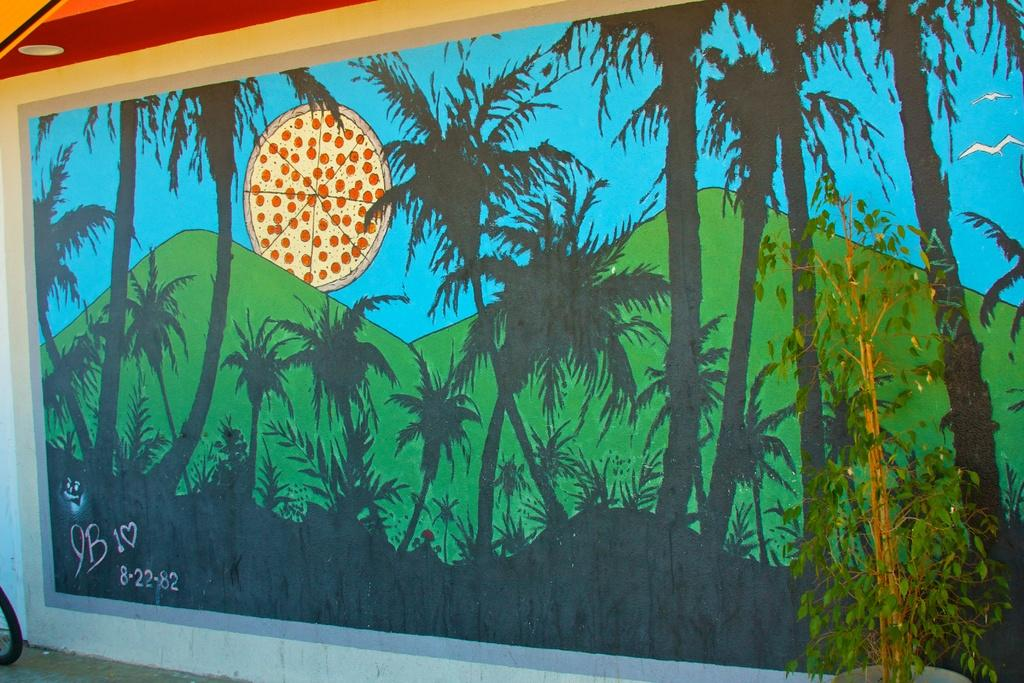What is on the wall in the image? There is a painting on a wall in the image. What does the painting depict? The painting depicts a beautiful scenery. Can you describe the scenery in the painting? The scenery includes mountains. Is there anything else in the scenery besides the mountains? Yes, there is an image of a pizza behind the mountains in the painting. What type of drum can be heard playing in the background of the image? There is no drum or sound present in the image; it is a painting on a wall. 